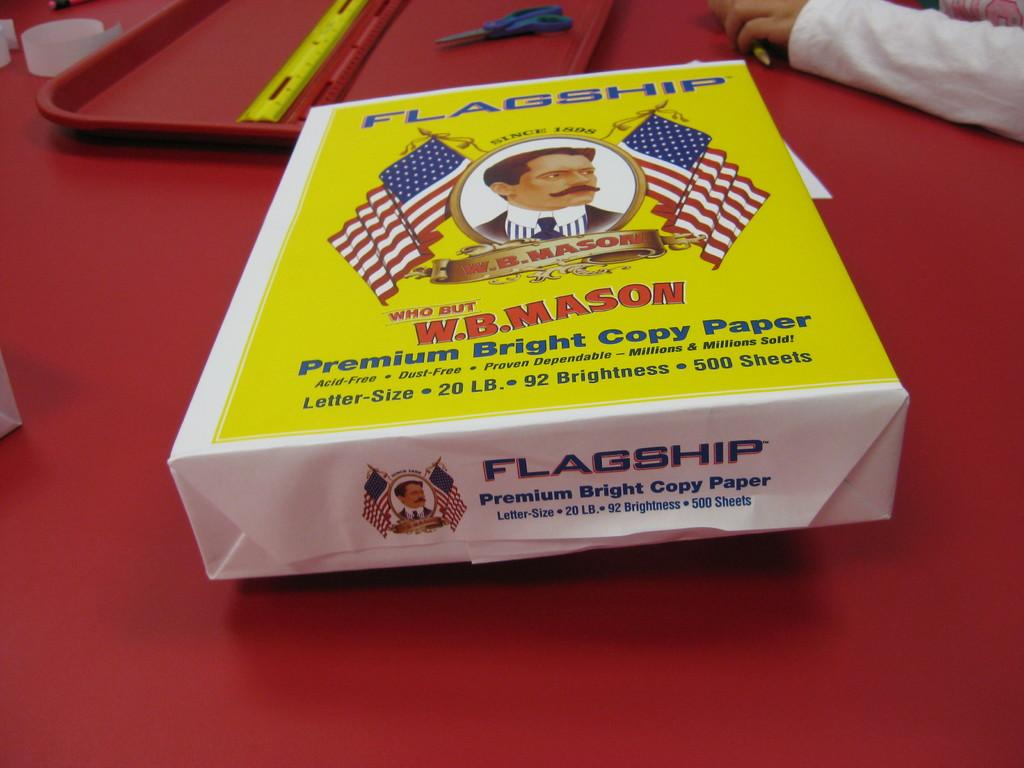Provide a one-sentence caption for the provided image. A ream of Flagship Premium Bright Copy Paper sits on a red table. 